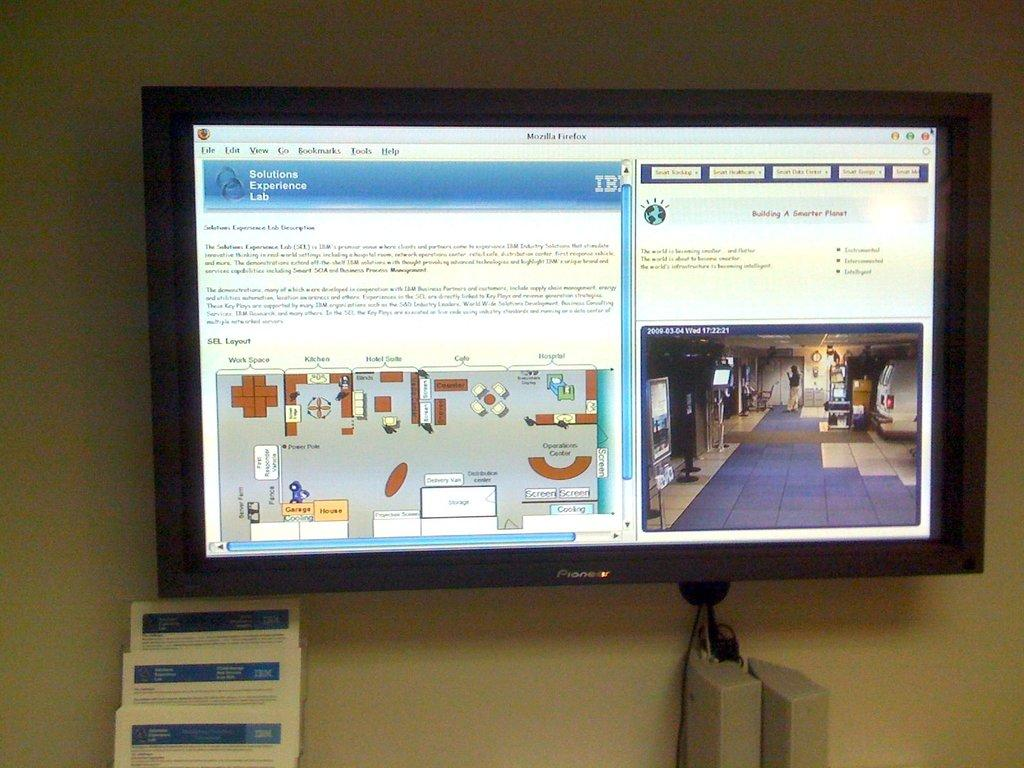<image>
Present a compact description of the photo's key features. A webpage is open to a page called Solutions Experience Lab. 